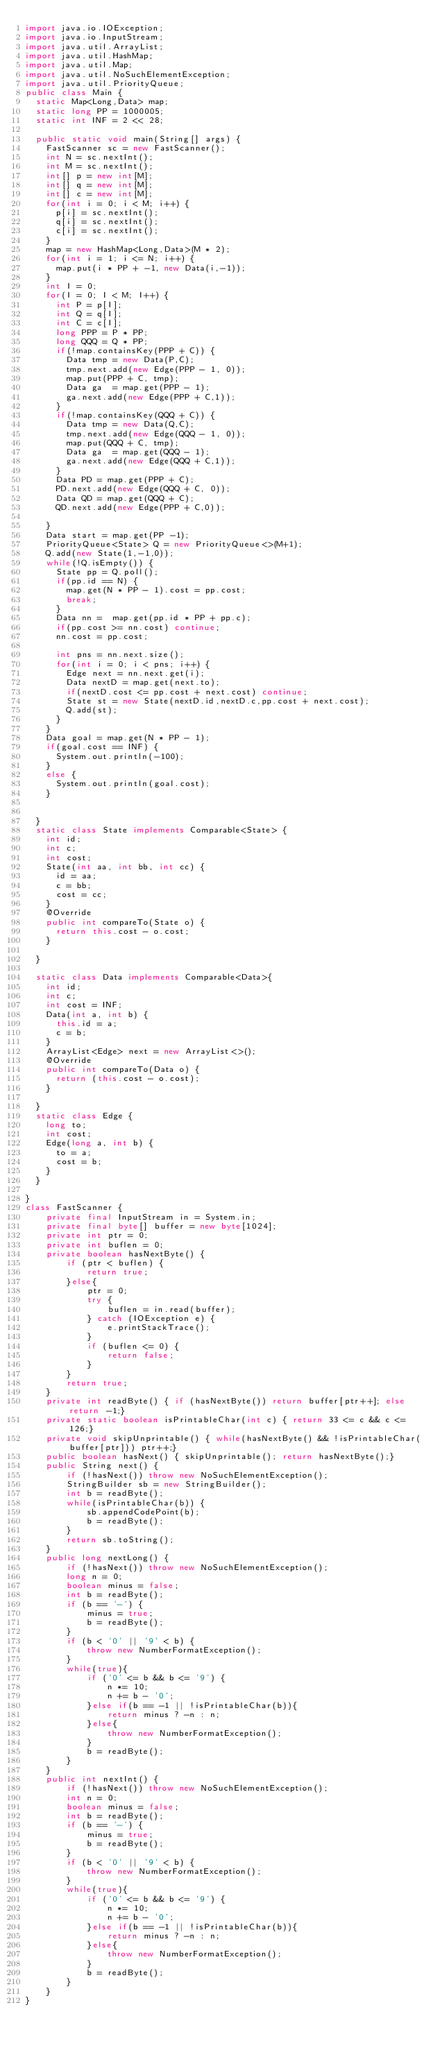<code> <loc_0><loc_0><loc_500><loc_500><_Java_>import java.io.IOException;
import java.io.InputStream;
import java.util.ArrayList;
import java.util.HashMap;
import java.util.Map;
import java.util.NoSuchElementException;
import java.util.PriorityQueue;
public class Main {
	static Map<Long,Data> map;
	static long PP = 1000005;
	static int INF = 2 << 28;
 
	public static void main(String[] args) {
		FastScanner sc = new FastScanner();
		int N = sc.nextInt();
		int M = sc.nextInt();
		int[] p = new int[M];
		int[] q = new int[M];
		int[] c = new int[M];
		for(int i = 0; i < M; i++) {
			p[i] = sc.nextInt();
			q[i] = sc.nextInt();
			c[i] = sc.nextInt();
		}
		map = new HashMap<Long,Data>(M * 2);
		for(int i = 1; i <= N; i++) {
			map.put(i * PP + -1, new Data(i,-1));
		}
		int I = 0;
		for(I = 0; I < M; I++) {
			int P = p[I];
			int Q = q[I];
			int C = c[I];
			long PPP = P * PP;
			long QQQ = Q * PP;
			if(!map.containsKey(PPP + C)) {
				Data tmp = new Data(P,C);
				tmp.next.add(new Edge(PPP - 1, 0));
				map.put(PPP + C, tmp);
				Data ga  = map.get(PPP - 1);
				ga.next.add(new Edge(PPP + C,1));
			}
			if(!map.containsKey(QQQ + C)) {
				Data tmp = new Data(Q,C);
				tmp.next.add(new Edge(QQQ - 1, 0));
				map.put(QQQ + C, tmp);
				Data ga  = map.get(QQQ - 1);
				ga.next.add(new Edge(QQQ + C,1));
			}
			Data PD = map.get(PPP + C);
			PD.next.add(new Edge(QQQ + C, 0));
			Data QD = map.get(QQQ + C);
			QD.next.add(new Edge(PPP + C,0));
 
		}
		Data start = map.get(PP -1);
		PriorityQueue<State> Q = new PriorityQueue<>(M+1);
		Q.add(new State(1,-1,0));
		while(!Q.isEmpty()) {
			State pp = Q.poll();
			if(pp.id == N) {
				map.get(N * PP - 1).cost = pp.cost;
				break;
			}
			Data nn =  map.get(pp.id * PP + pp.c);
			if(pp.cost >= nn.cost) continue;
			nn.cost = pp.cost;
			
			int pns = nn.next.size();
			for(int i = 0; i < pns; i++) {
				Edge next = nn.next.get(i);
				Data nextD = map.get(next.to);
				if(nextD.cost <= pp.cost + next.cost) continue;
				State st = new State(nextD.id,nextD.c,pp.cost + next.cost);
				Q.add(st);
			}
		}
		Data goal = map.get(N * PP - 1);
		if(goal.cost == INF) {
			System.out.println(-100);
		}
		else {
			System.out.println(goal.cost);
		}
		
		
	}
	static class State implements Comparable<State> {
		int id;
		int c;
		int cost;
		State(int aa, int bb, int cc) {
			id = aa;
			c = bb;
			cost = cc;
		}
		@Override
		public int compareTo(State o) {
			return this.cost - o.cost;
		}
		
	}
 
	static class Data implements Comparable<Data>{
		int id;
		int c;
		int cost = INF;
		Data(int a, int b) {
			this.id = a;
			c = b;
		}
		ArrayList<Edge> next = new ArrayList<>();
		@Override
		public int compareTo(Data o) {
			return (this.cost - o.cost);
		}
		
	}
	static class Edge {
		long to;
		int cost;
		Edge(long a, int b) {
			to = a;
			cost = b;
		}
	}
 
}
class FastScanner {
    private final InputStream in = System.in;
    private final byte[] buffer = new byte[1024];
    private int ptr = 0;
    private int buflen = 0;
    private boolean hasNextByte() {
        if (ptr < buflen) {
            return true;
        }else{
            ptr = 0;
            try {
                buflen = in.read(buffer);
            } catch (IOException e) {
                e.printStackTrace();
            }
            if (buflen <= 0) {
                return false;
            }
        }
        return true;
    }
    private int readByte() { if (hasNextByte()) return buffer[ptr++]; else return -1;}
    private static boolean isPrintableChar(int c) { return 33 <= c && c <= 126;}
    private void skipUnprintable() { while(hasNextByte() && !isPrintableChar(buffer[ptr])) ptr++;}
    public boolean hasNext() { skipUnprintable(); return hasNextByte();}
    public String next() {
        if (!hasNext()) throw new NoSuchElementException();
        StringBuilder sb = new StringBuilder();
        int b = readByte();
        while(isPrintableChar(b)) {
            sb.appendCodePoint(b);
            b = readByte();
        }
        return sb.toString();
    }
    public long nextLong() {
        if (!hasNext()) throw new NoSuchElementException();
        long n = 0;
        boolean minus = false;
        int b = readByte();
        if (b == '-') {
            minus = true;
            b = readByte();
        }
        if (b < '0' || '9' < b) {
            throw new NumberFormatException();
        }
        while(true){
            if ('0' <= b && b <= '9') {
                n *= 10;
                n += b - '0';
            }else if(b == -1 || !isPrintableChar(b)){
                return minus ? -n : n;
            }else{
                throw new NumberFormatException();
            }
            b = readByte();
        }
    }
    public int nextInt() {
        if (!hasNext()) throw new NoSuchElementException();
        int n = 0;
        boolean minus = false;
        int b = readByte();
        if (b == '-') {
            minus = true;
            b = readByte();
        }
        if (b < '0' || '9' < b) {
            throw new NumberFormatException();
        }
        while(true){
            if ('0' <= b && b <= '9') {
                n *= 10;
                n += b - '0';
            }else if(b == -1 || !isPrintableChar(b)){
                return minus ? -n : n;
            }else{
                throw new NumberFormatException();
            }
            b = readByte();
        }
    }
}</code> 